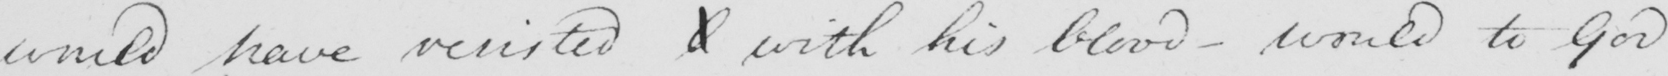Can you read and transcribe this handwriting? would have resisted  <gap/>  with his blood - would to God 